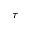<formula> <loc_0><loc_0><loc_500><loc_500>\tau</formula> 